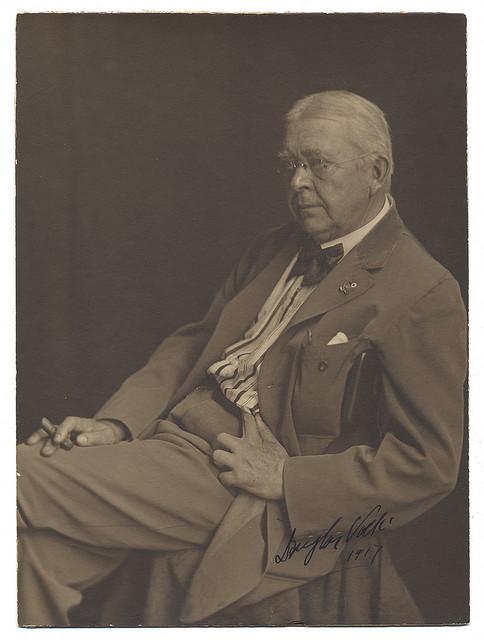Is the man wearing a tie?
Keep it brief. Yes. What color is the man's hair?
Concise answer only. White. Did the man just wake up?
Write a very short answer. No. Was this photo taken in the year 1989?
Quick response, please. No. What kind of pants are being worn?
Quick response, please. Dress pants. Is this man someone's ancestor?
Short answer required. Yes. 